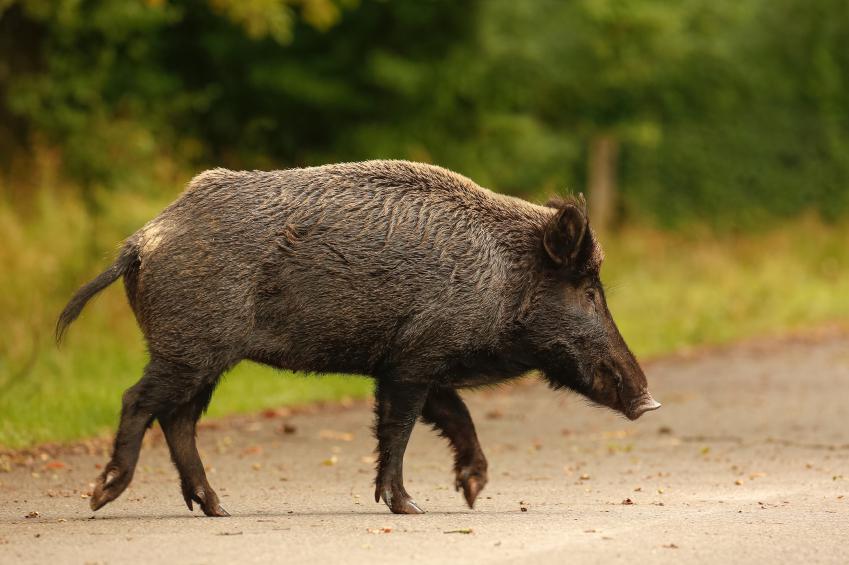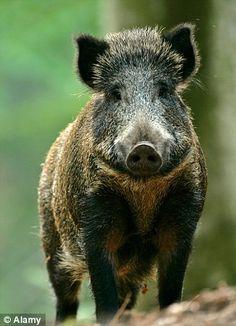The first image is the image on the left, the second image is the image on the right. Evaluate the accuracy of this statement regarding the images: "The pig in the image on the left is facing the camera.". Is it true? Answer yes or no. No. The first image is the image on the left, the second image is the image on the right. For the images shown, is this caption "One image shows a single wild pig with its head and body facing forward, and the other image shows a single standing wild pig with its head and body in profile." true? Answer yes or no. Yes. 